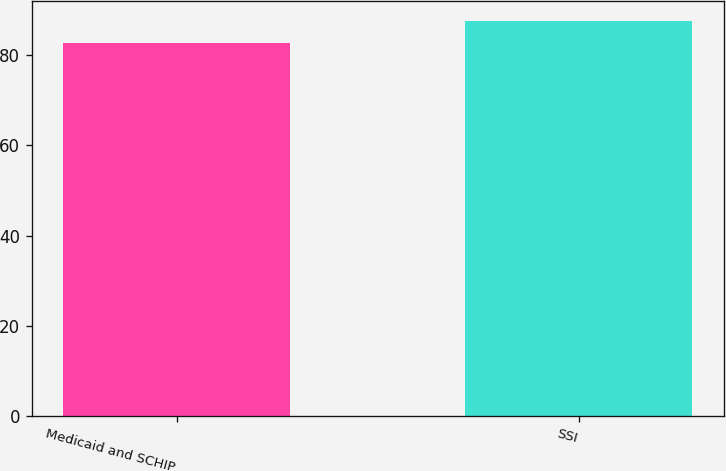<chart> <loc_0><loc_0><loc_500><loc_500><bar_chart><fcel>Medicaid and SCHIP<fcel>SSI<nl><fcel>82.6<fcel>87.6<nl></chart> 